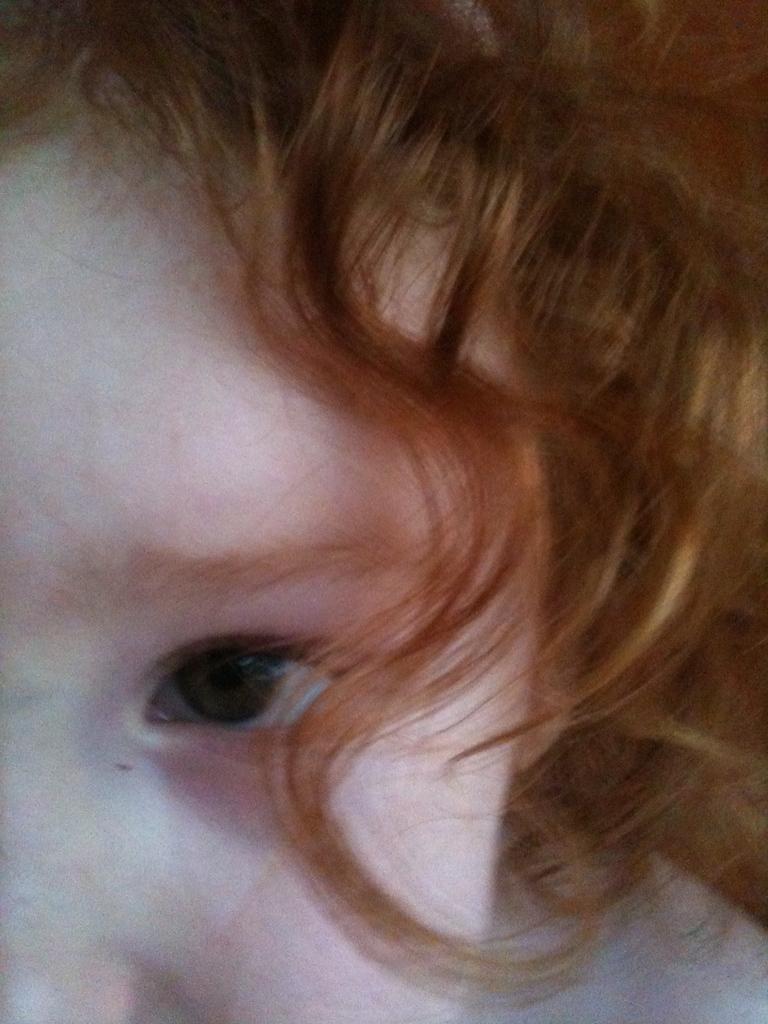Please provide a concise description of this image. In this picture there is a baby with red hair. 